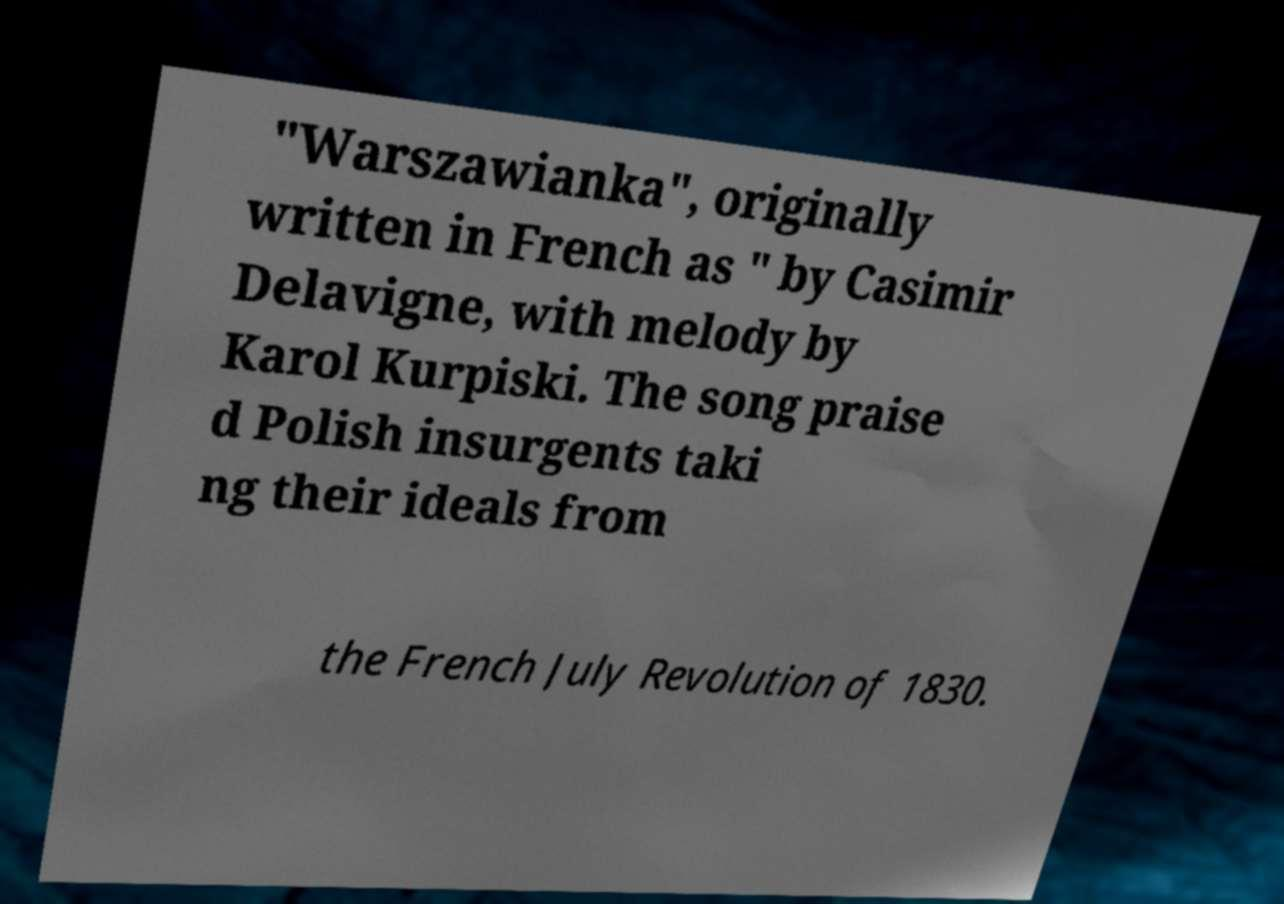For documentation purposes, I need the text within this image transcribed. Could you provide that? "Warszawianka", originally written in French as " by Casimir Delavigne, with melody by Karol Kurpiski. The song praise d Polish insurgents taki ng their ideals from the French July Revolution of 1830. 